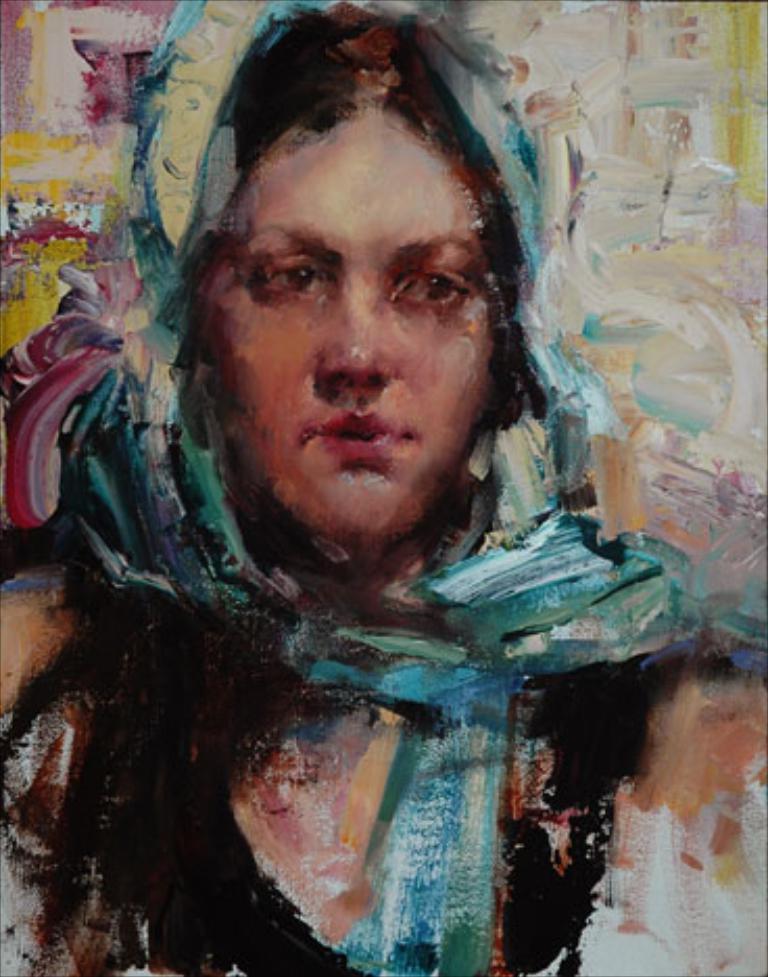How would you summarize this image in a sentence or two? In this image I can see an art of the woman. They are in different colors. 